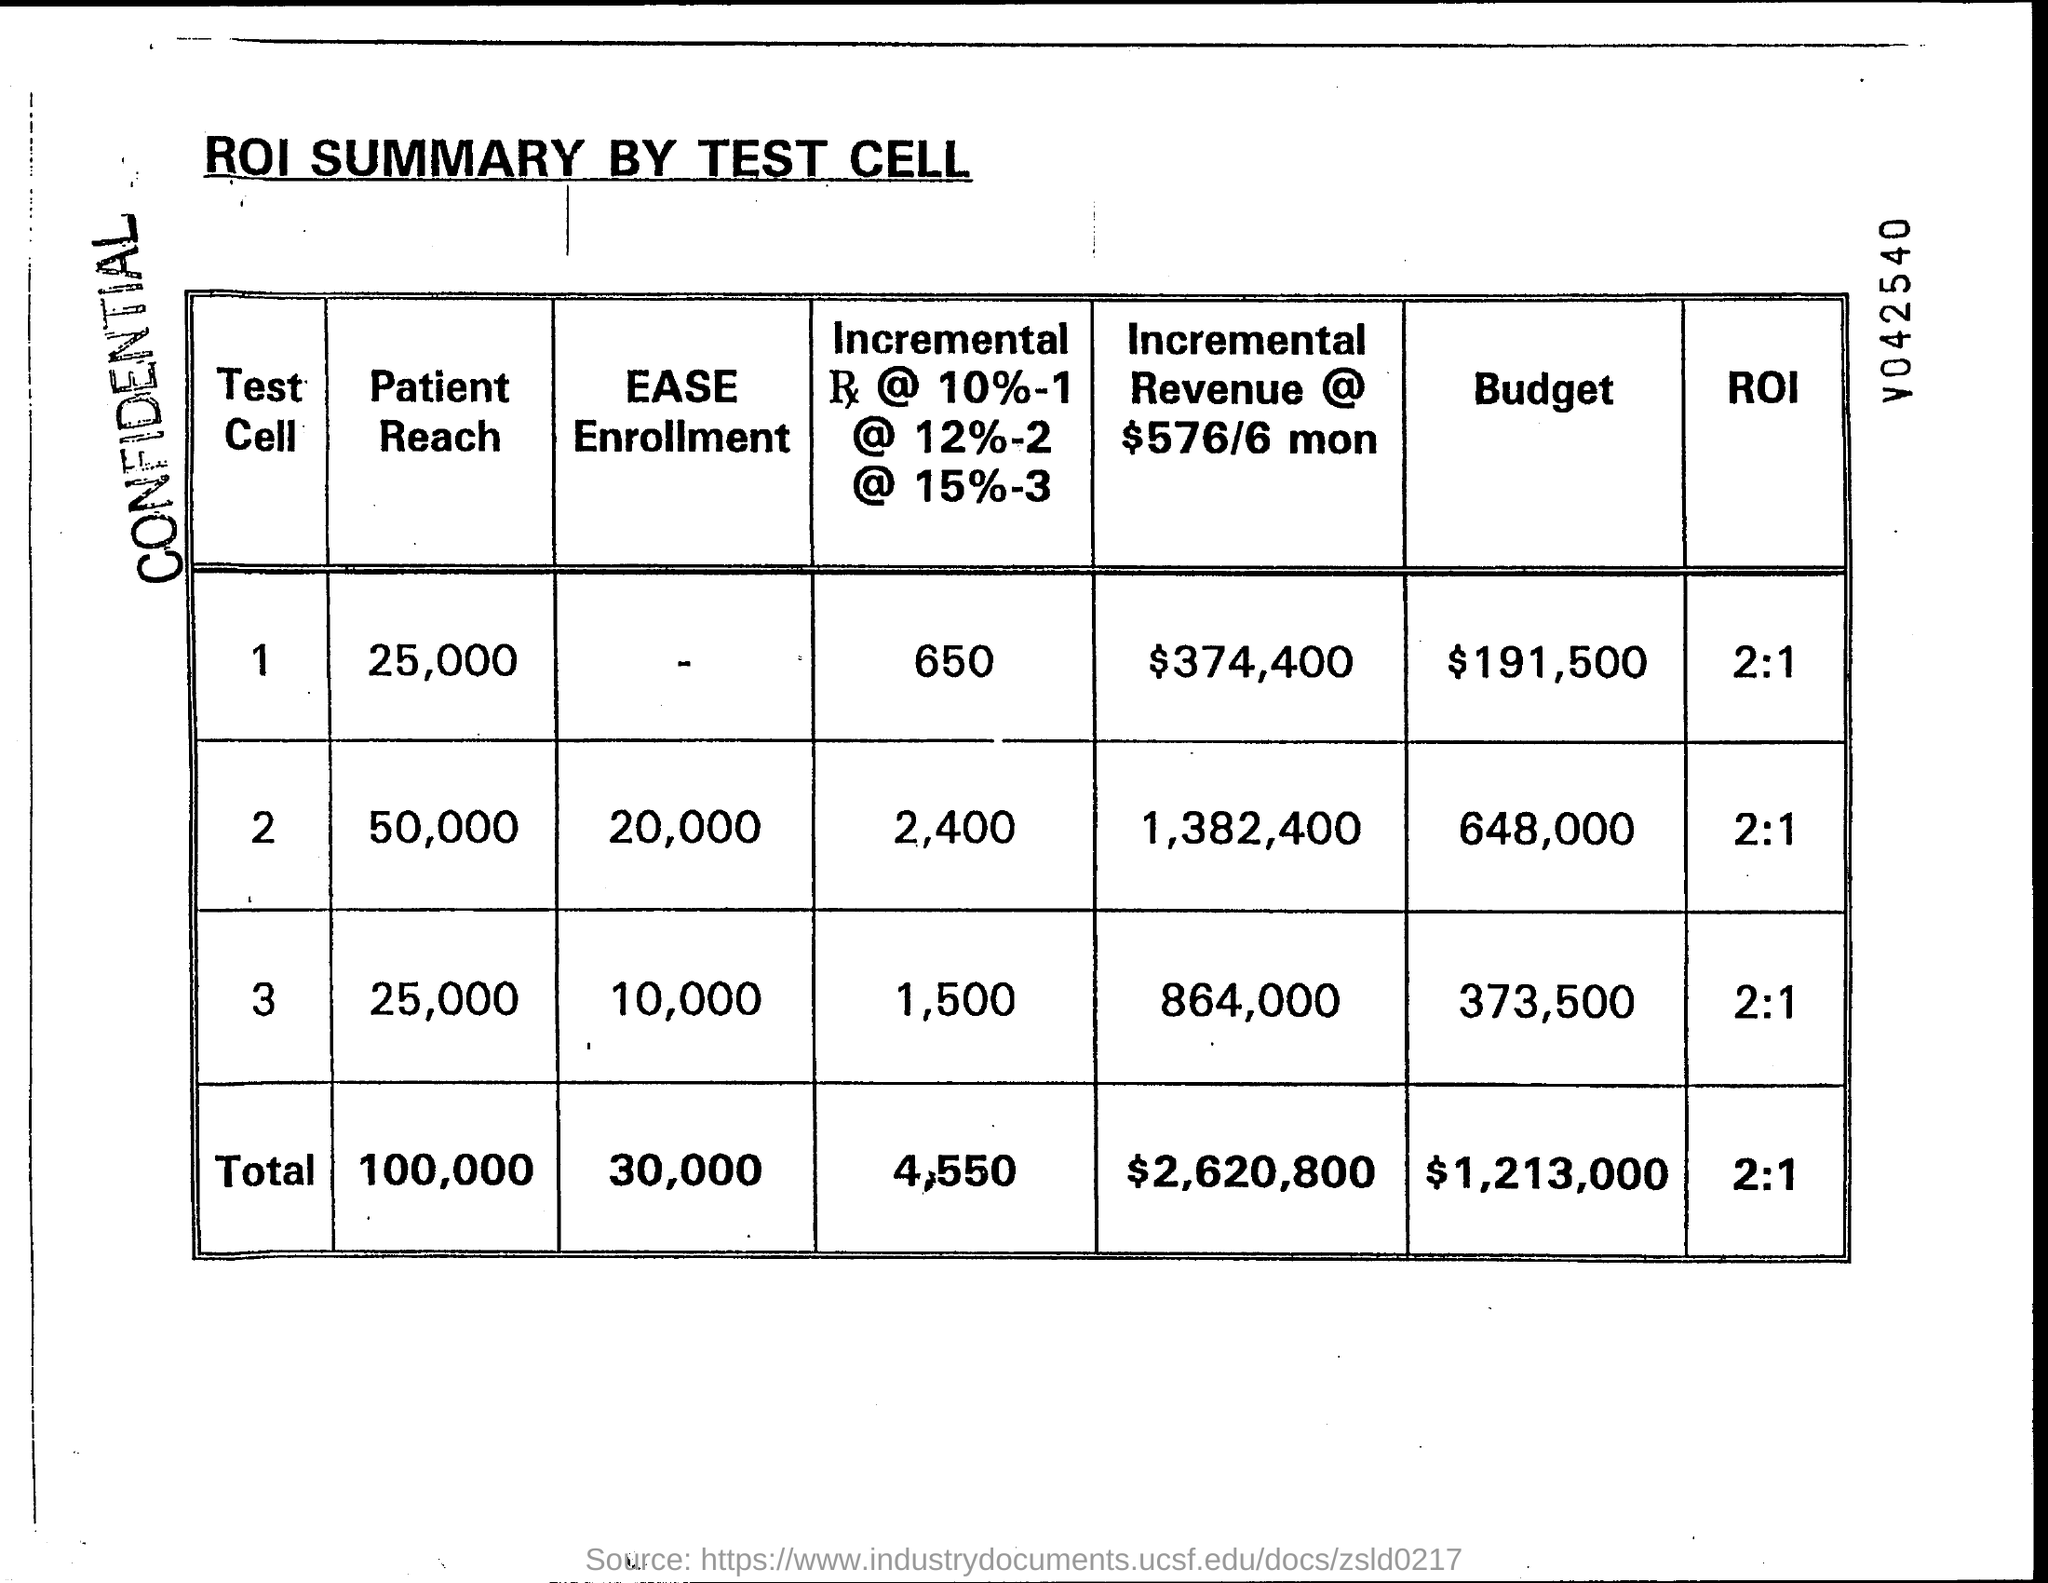Can you explain what 'Patient Reach' and 'EASE Enrollment' columns represent in this table? In the context of the ROI SUMMARY BY TEST CELL displayed in the image, 'Patient Reach' likely refers to the number of patients accessed or targeted as part of a medical test or trial. 'EASE Enrollment' may refer to the number of patients who enrolled in a test or program designed to evaluate the EASE (Efficiency, Accessibility, and Simplicity in Enrollment) of a healthcare intervention or process. 